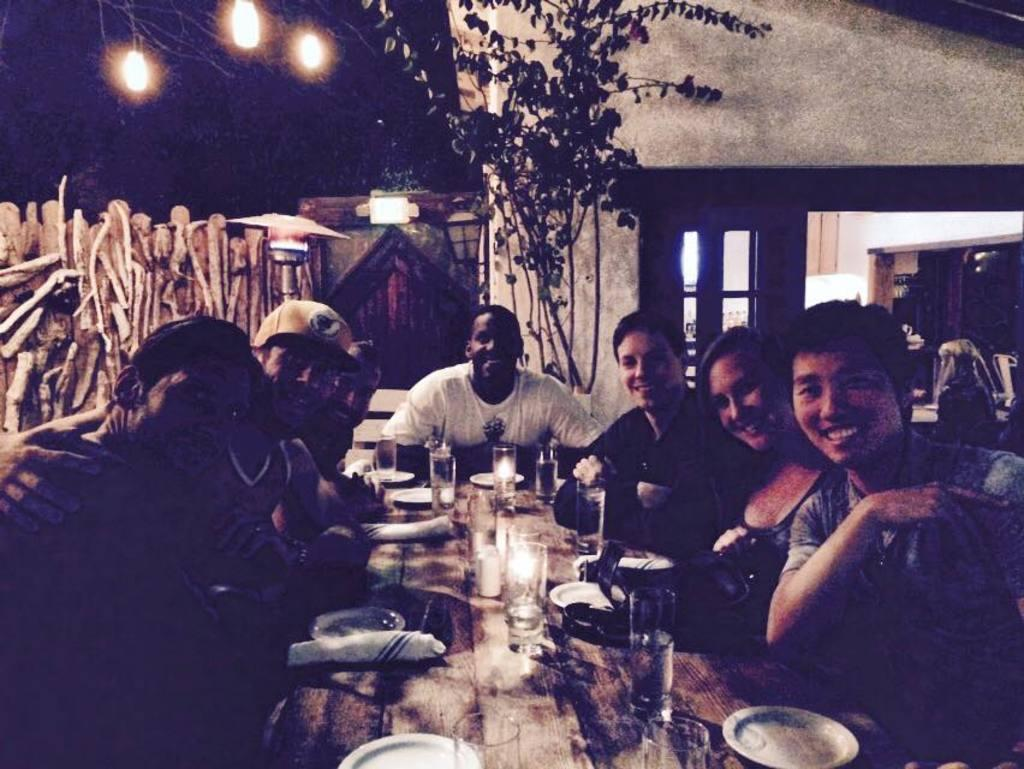What are the people in the image doing? There is a group of people sitting on chairs in the image. What objects can be seen on the table? There is a glass, a plate, a candle, and a cloth on the table in the image. What material is visible in the image? There is some wood visible in the image. What type of lighting is present in the image? There are lights present in the image. What natural elements can be seen in the image? There is a tree and a house in the image. What type of yarn is being used to create the tree in the image? There is no yarn present in the image; the tree is a natural element. How many balls are visible in the image? There are no balls visible in the image. 